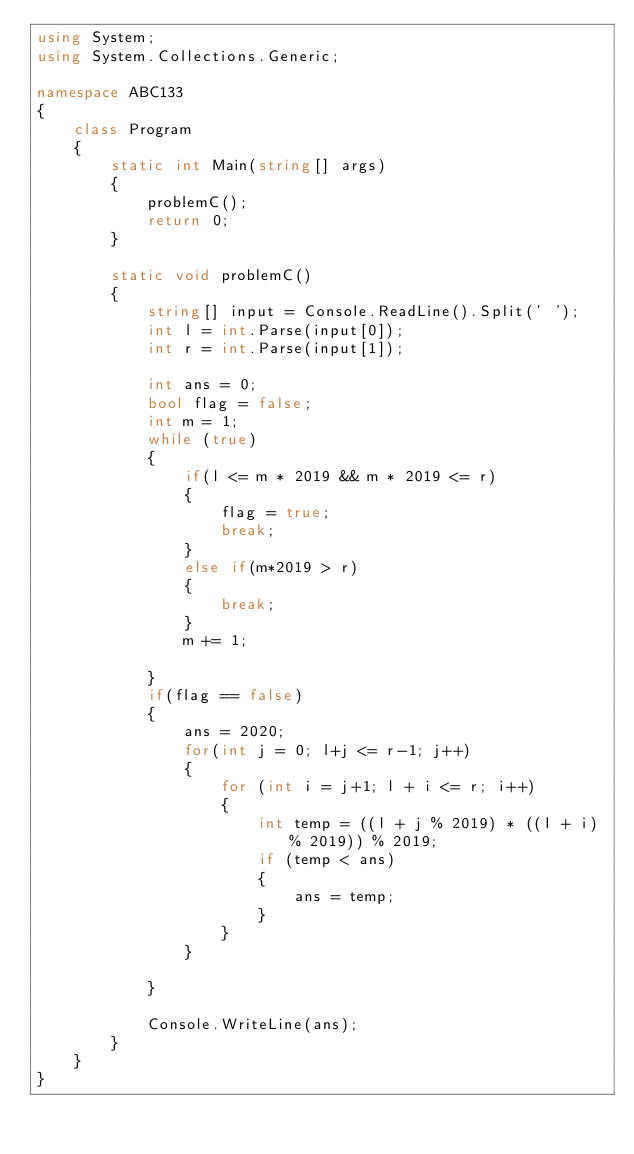Convert code to text. <code><loc_0><loc_0><loc_500><loc_500><_C#_>using System;
using System.Collections.Generic;

namespace ABC133
{
    class Program
    {
        static int Main(string[] args)
        {
            problemC();
            return 0;
        }

        static void problemC()
        {
            string[] input = Console.ReadLine().Split(' ');
            int l = int.Parse(input[0]);
            int r = int.Parse(input[1]);

            int ans = 0;
            bool flag = false;
            int m = 1;
            while (true)
            {
                if(l <= m * 2019 && m * 2019 <= r)
                {
                    flag = true;
                    break;
                }
                else if(m*2019 > r)
                {
                    break;
                }
                m += 1;
                
            }
            if(flag == false)
            {
                ans = 2020;
                for(int j = 0; l+j <= r-1; j++)
                {
                    for (int i = j+1; l + i <= r; i++)
                    {
                        int temp = ((l + j % 2019) * ((l + i) % 2019)) % 2019;
                        if (temp < ans)
                        {
                            ans = temp;
                        }
                    }
                }
                
            }

            Console.WriteLine(ans);
        }
    }
}</code> 